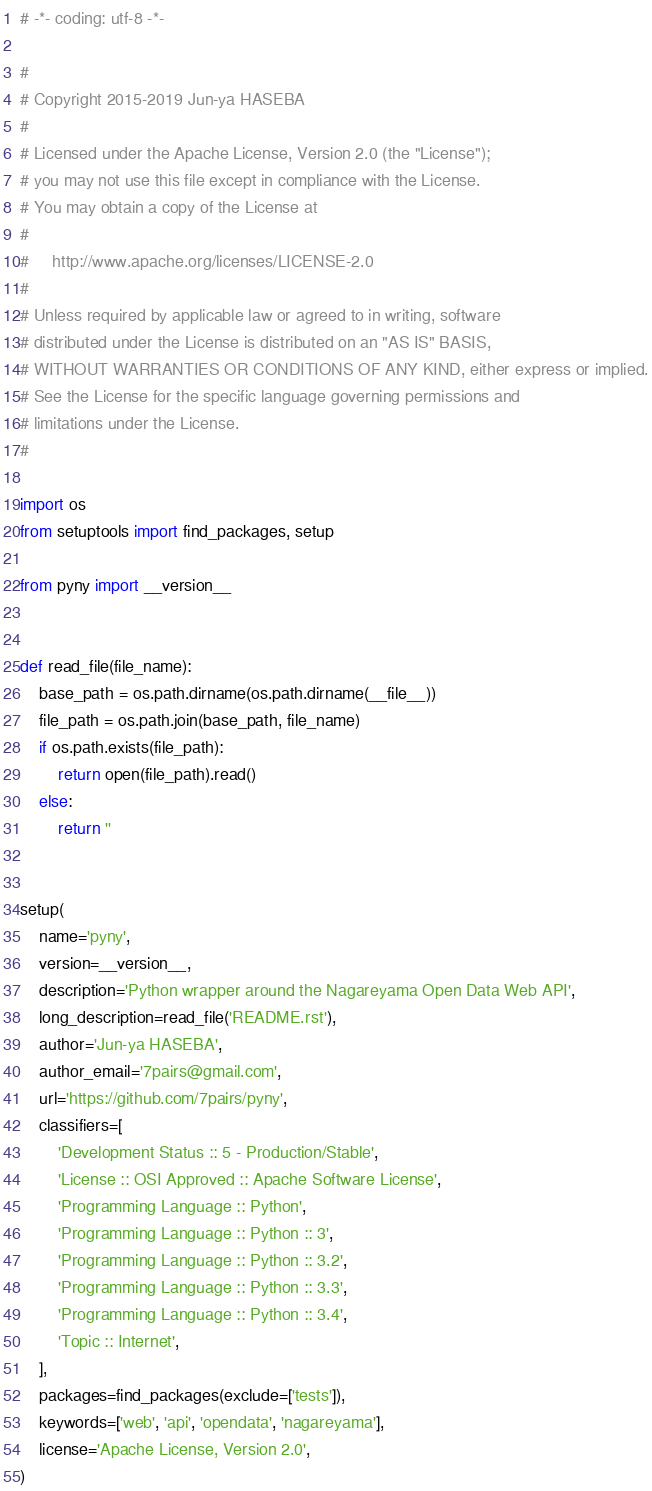<code> <loc_0><loc_0><loc_500><loc_500><_Python_># -*- coding: utf-8 -*-

#
# Copyright 2015-2019 Jun-ya HASEBA
#
# Licensed under the Apache License, Version 2.0 (the "License");
# you may not use this file except in compliance with the License.
# You may obtain a copy of the License at
#
#     http://www.apache.org/licenses/LICENSE-2.0
#
# Unless required by applicable law or agreed to in writing, software
# distributed under the License is distributed on an "AS IS" BASIS,
# WITHOUT WARRANTIES OR CONDITIONS OF ANY KIND, either express or implied.
# See the License for the specific language governing permissions and
# limitations under the License.
#

import os
from setuptools import find_packages, setup

from pyny import __version__


def read_file(file_name):
    base_path = os.path.dirname(os.path.dirname(__file__))
    file_path = os.path.join(base_path, file_name)
    if os.path.exists(file_path):
        return open(file_path).read()
    else:
        return ''


setup(
    name='pyny',
    version=__version__,
    description='Python wrapper around the Nagareyama Open Data Web API',
    long_description=read_file('README.rst'),
    author='Jun-ya HASEBA',
    author_email='7pairs@gmail.com',
    url='https://github.com/7pairs/pyny',
    classifiers=[
        'Development Status :: 5 - Production/Stable',
        'License :: OSI Approved :: Apache Software License',
        'Programming Language :: Python',
        'Programming Language :: Python :: 3',
        'Programming Language :: Python :: 3.2',
        'Programming Language :: Python :: 3.3',
        'Programming Language :: Python :: 3.4',
        'Topic :: Internet',
    ],
    packages=find_packages(exclude=['tests']),
    keywords=['web', 'api', 'opendata', 'nagareyama'],
    license='Apache License, Version 2.0',
)
</code> 